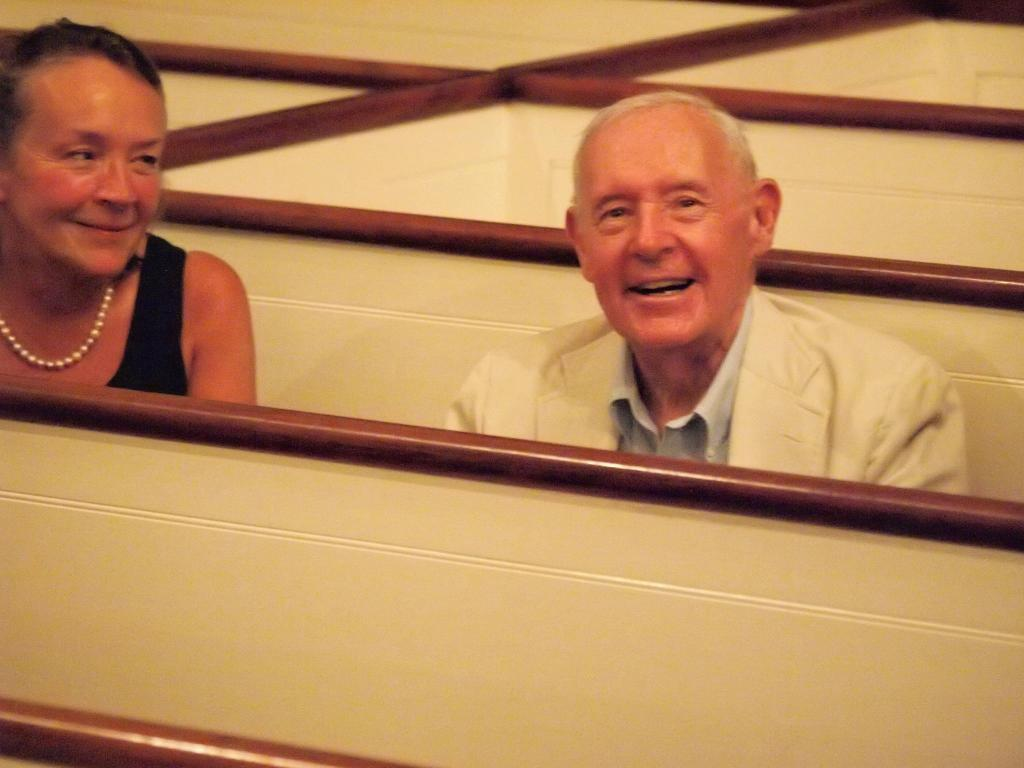How many people are present in the image? There is a man and a woman in the image. What can be seen at the bottom of the image? There is a wooden object at the bottom of the image. What type of objects can be seen in the background of the image? There are wooden objects visible in the background of the image. What type of memory does the man have in the image? There is no indication of any memory or object related to memory in the image. 